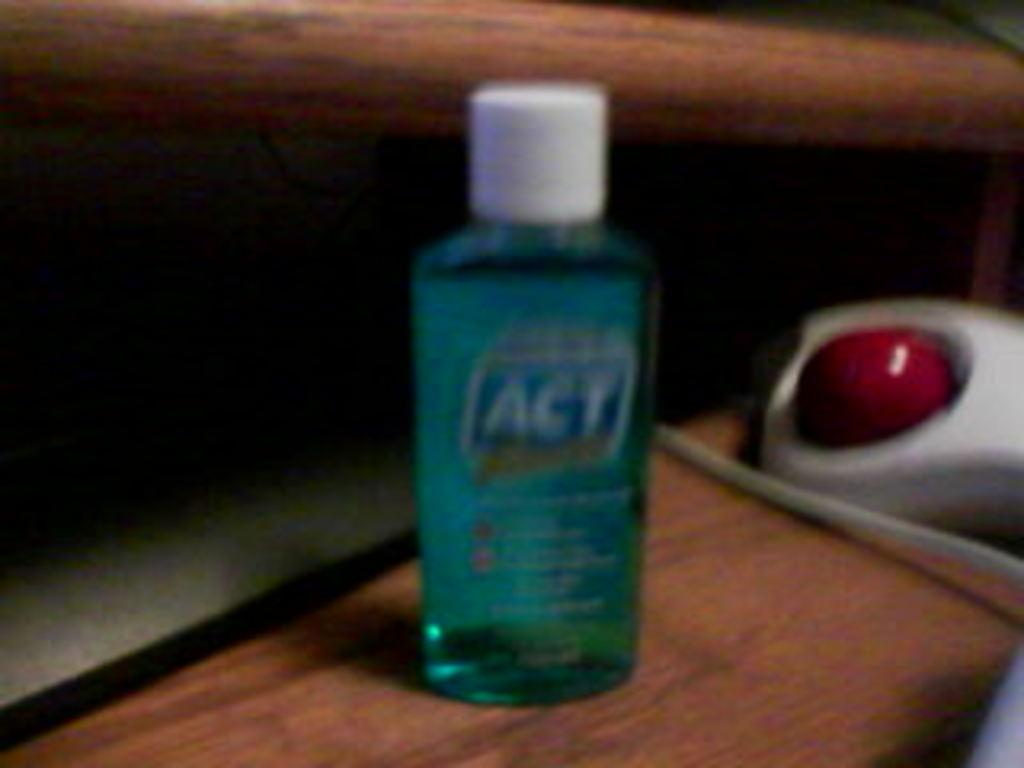<image>
Share a concise interpretation of the image provided. A small travel size bottle of ACT dental rinse next to a computer mouse. 